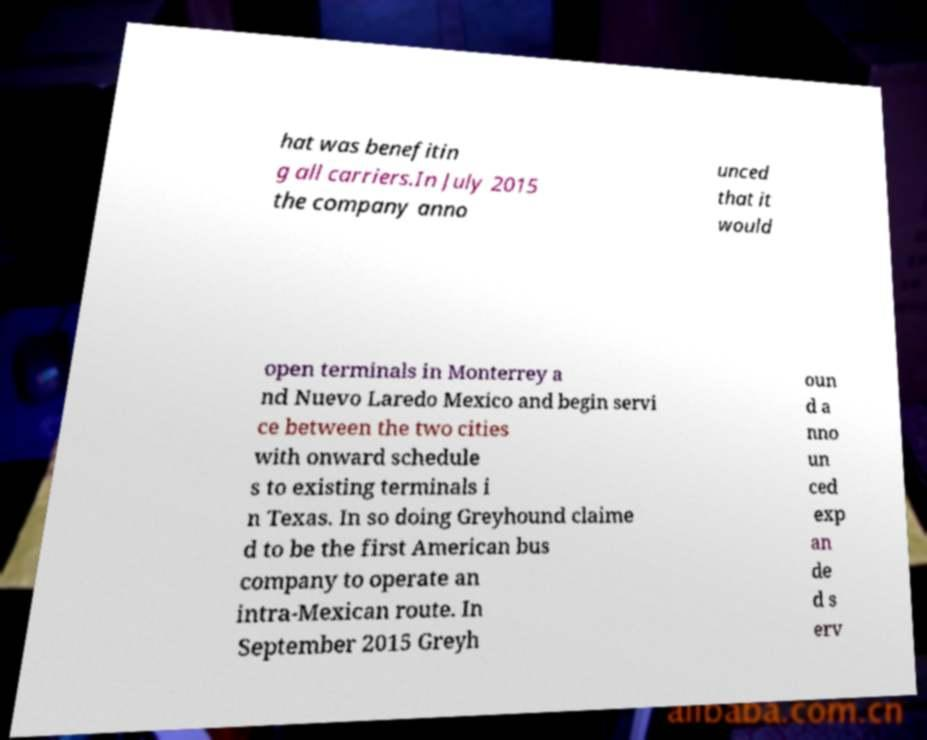Can you read and provide the text displayed in the image?This photo seems to have some interesting text. Can you extract and type it out for me? hat was benefitin g all carriers.In July 2015 the company anno unced that it would open terminals in Monterrey a nd Nuevo Laredo Mexico and begin servi ce between the two cities with onward schedule s to existing terminals i n Texas. In so doing Greyhound claime d to be the first American bus company to operate an intra-Mexican route. In September 2015 Greyh oun d a nno un ced exp an de d s erv 